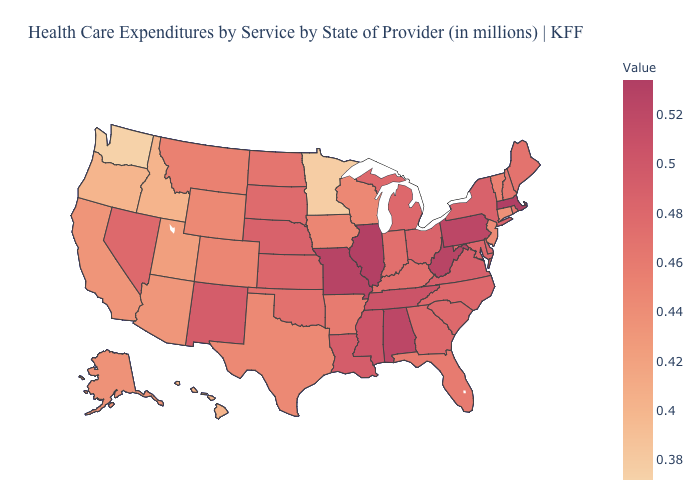Is the legend a continuous bar?
Short answer required. Yes. Among the states that border Idaho , does Montana have the lowest value?
Keep it brief. No. Is the legend a continuous bar?
Quick response, please. Yes. Among the states that border Florida , which have the highest value?
Answer briefly. Alabama. Does Massachusetts have the highest value in the USA?
Quick response, please. Yes. Does Idaho have the lowest value in the USA?
Keep it brief. No. Does Rhode Island have the highest value in the USA?
Be succinct. No. Which states have the lowest value in the USA?
Short answer required. Washington. Does Maine have a lower value than Minnesota?
Write a very short answer. No. 